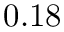Convert formula to latex. <formula><loc_0><loc_0><loc_500><loc_500>0 . 1 8</formula> 